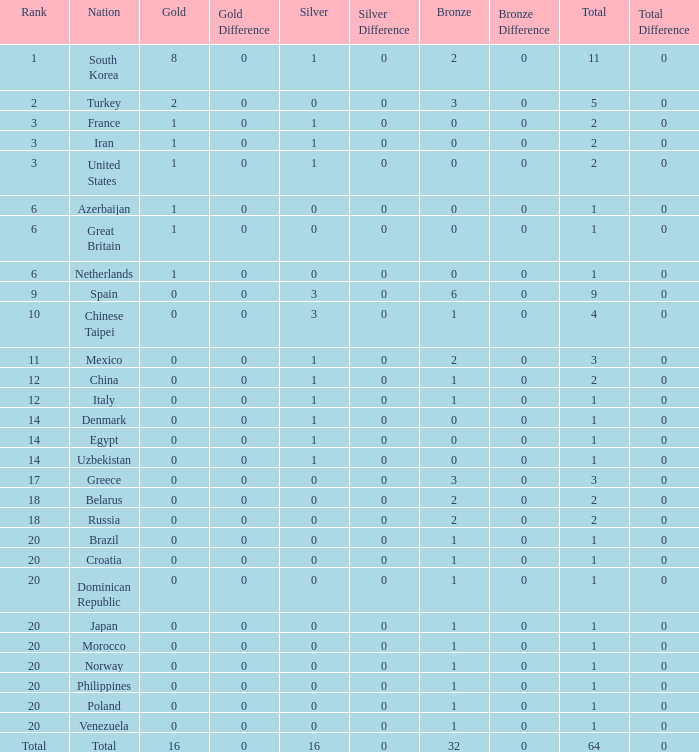What is the average total medals of the nation ranked 1 with less than 1 silver? None. 